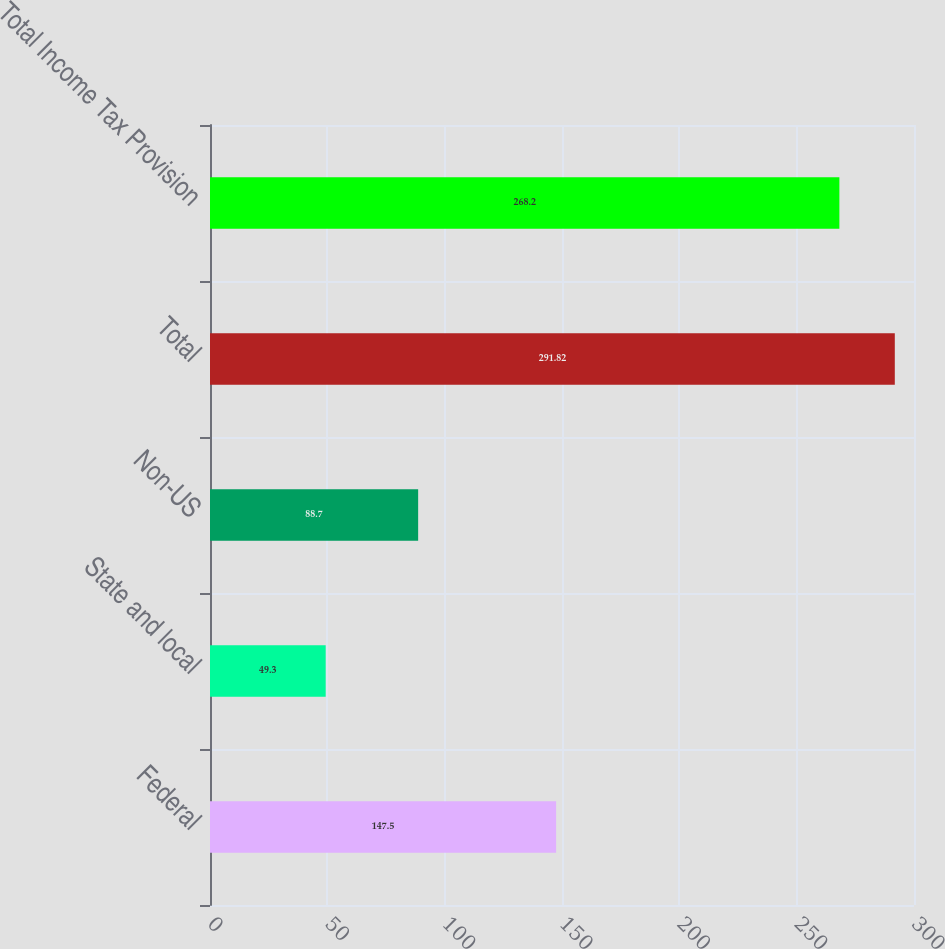Convert chart. <chart><loc_0><loc_0><loc_500><loc_500><bar_chart><fcel>Federal<fcel>State and local<fcel>Non-US<fcel>Total<fcel>Total Income Tax Provision<nl><fcel>147.5<fcel>49.3<fcel>88.7<fcel>291.82<fcel>268.2<nl></chart> 